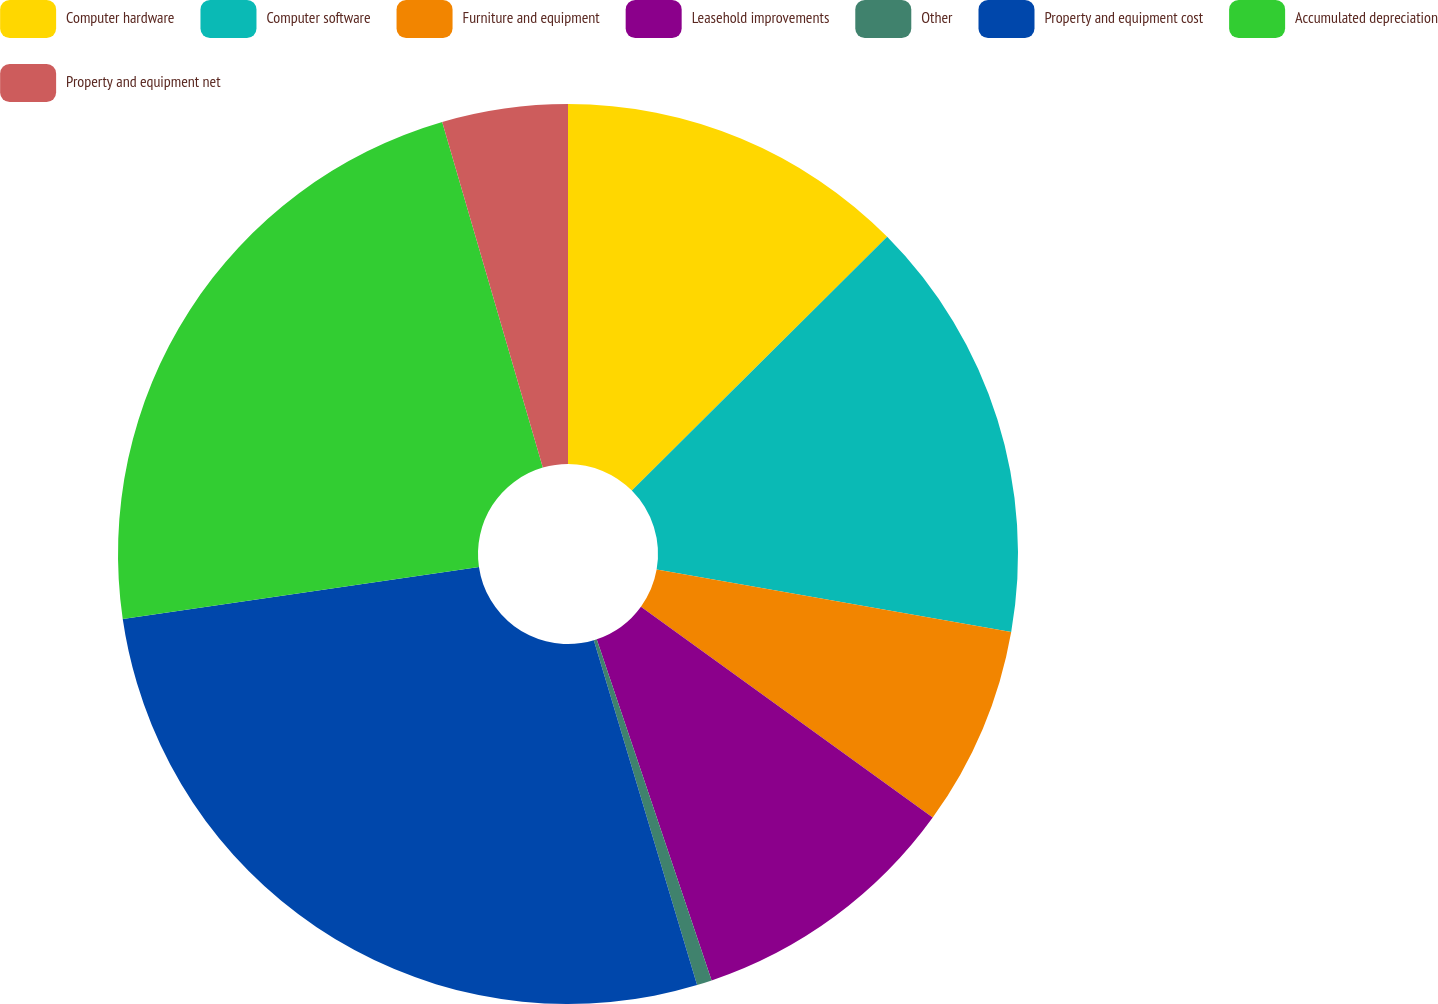<chart> <loc_0><loc_0><loc_500><loc_500><pie_chart><fcel>Computer hardware<fcel>Computer software<fcel>Furniture and equipment<fcel>Leasehold improvements<fcel>Other<fcel>Property and equipment cost<fcel>Accumulated depreciation<fcel>Property and equipment net<nl><fcel>12.55%<fcel>15.22%<fcel>7.19%<fcel>9.87%<fcel>0.54%<fcel>27.32%<fcel>22.8%<fcel>4.51%<nl></chart> 